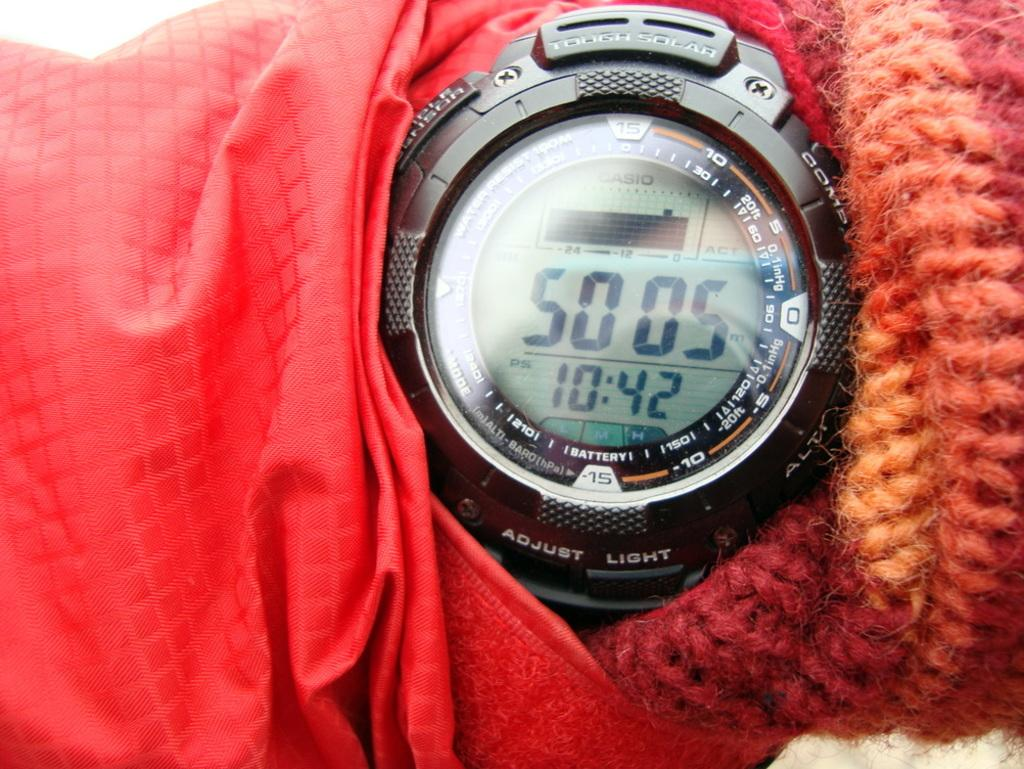<image>
Render a clear and concise summary of the photo. Someone wearing red has a watch on that says it is 10:42. 